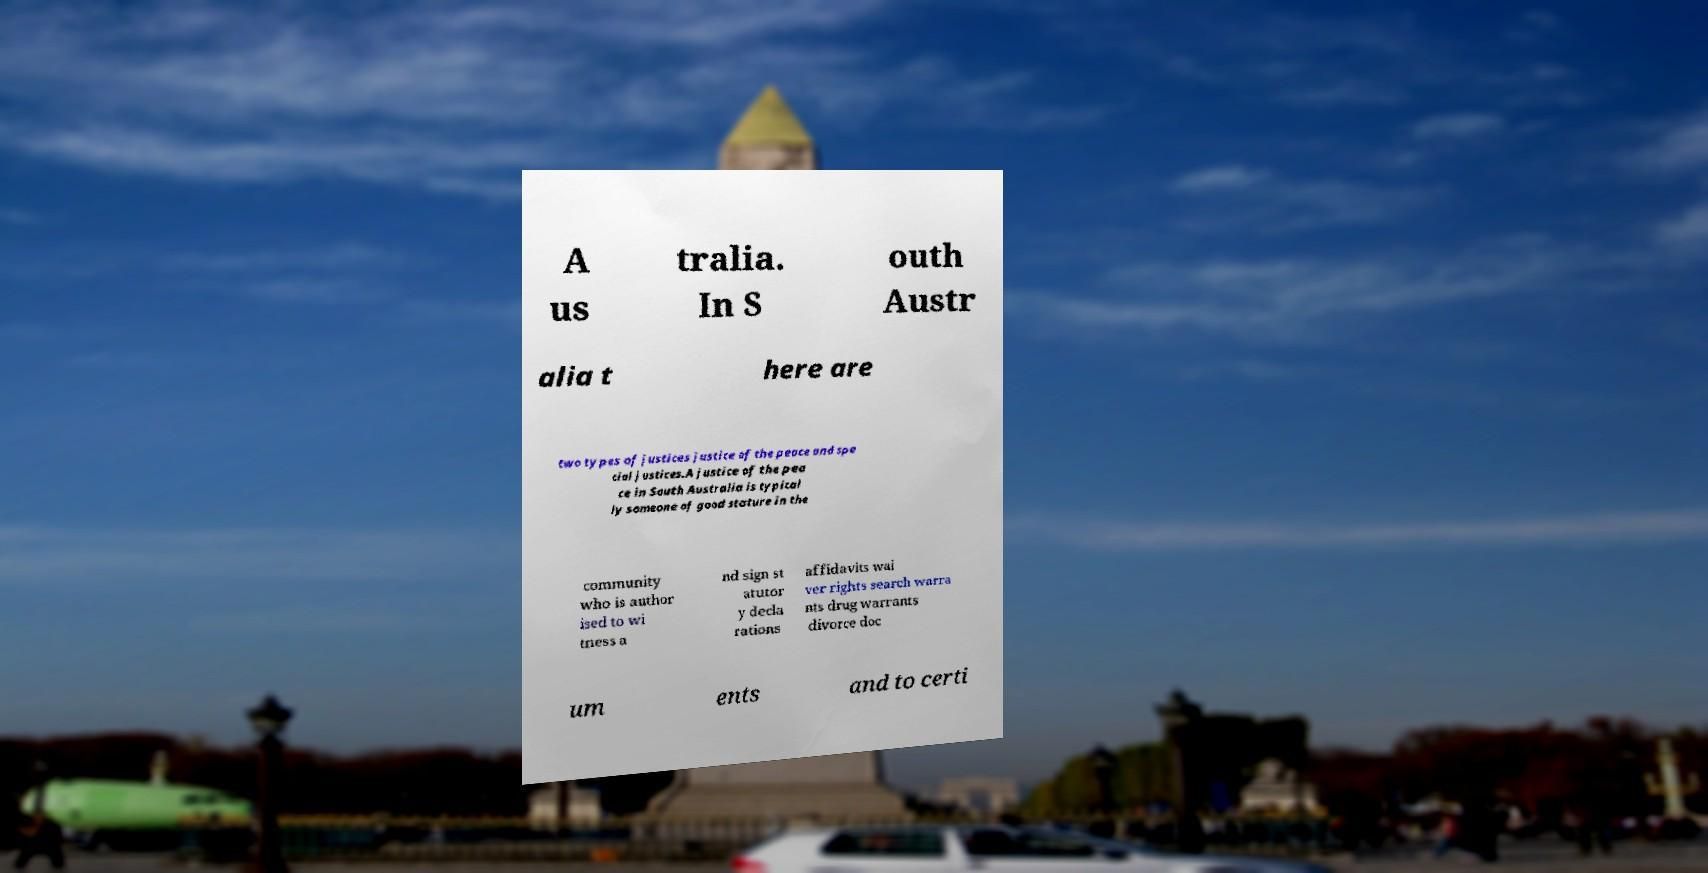What messages or text are displayed in this image? I need them in a readable, typed format. A us tralia. In S outh Austr alia t here are two types of justices justice of the peace and spe cial justices.A justice of the pea ce in South Australia is typical ly someone of good stature in the community who is author ised to wi tness a nd sign st atutor y decla rations affidavits wai ver rights search warra nts drug warrants divorce doc um ents and to certi 